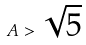<formula> <loc_0><loc_0><loc_500><loc_500>A > \sqrt { 5 }</formula> 